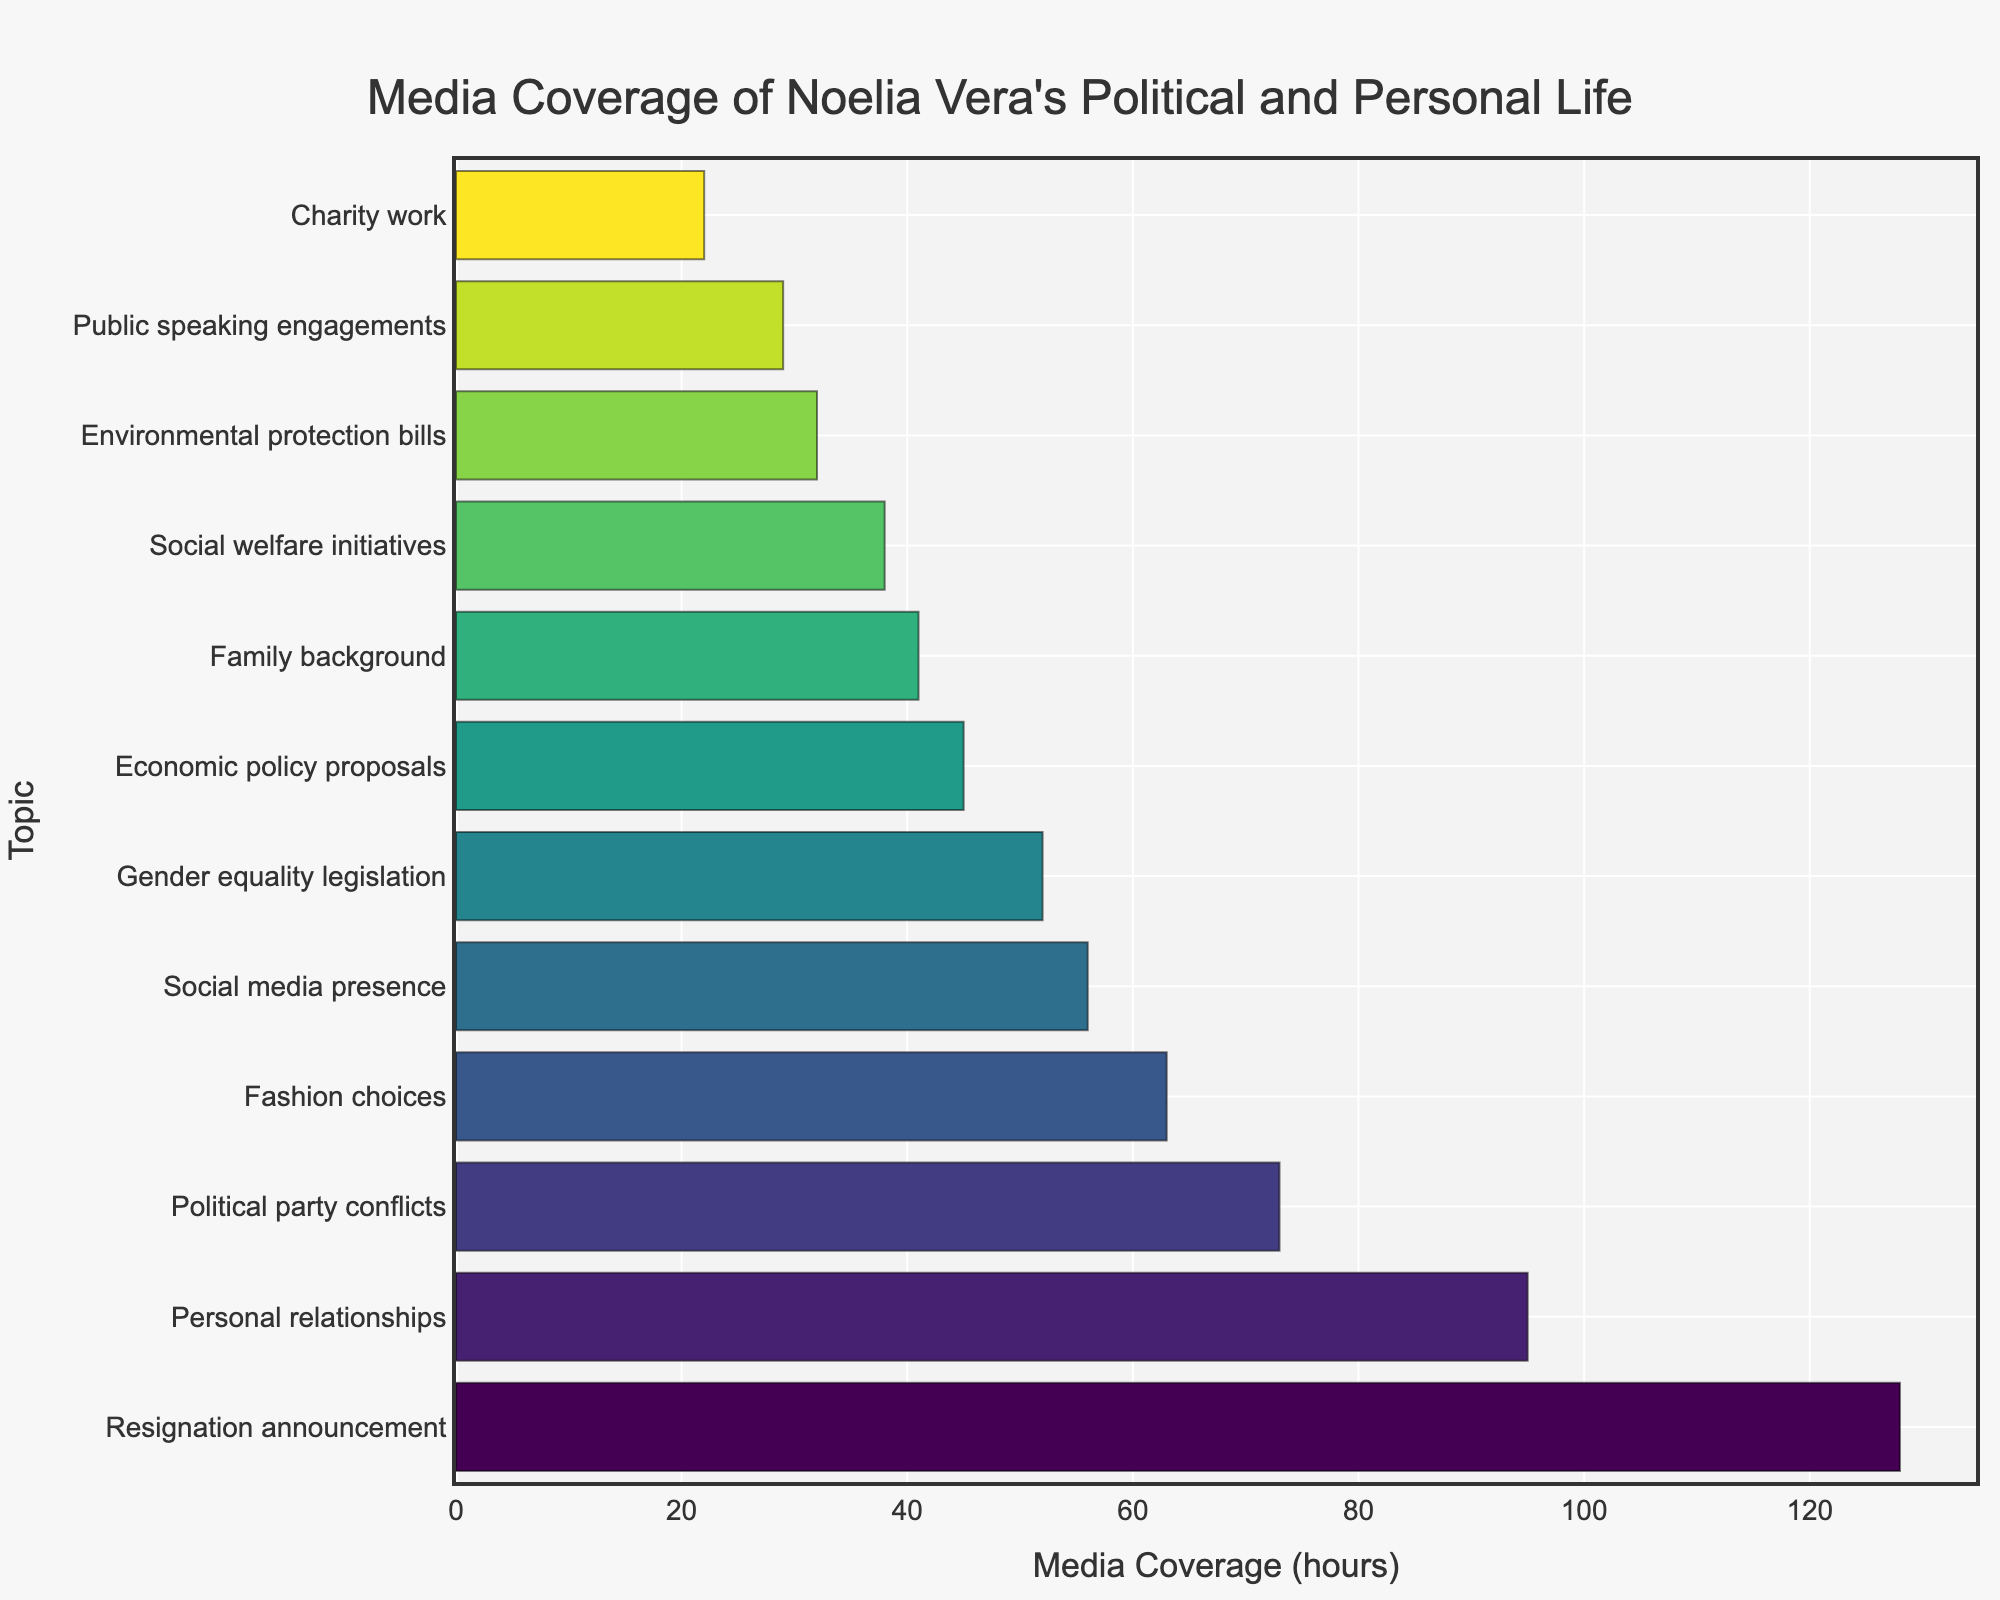What topic received the highest media coverage? The bar chart shows the 'Resignation announcement' with the longest bar on the horizontal axis, indicating it received the highest media coverage.
Answer: Resignation announcement How much more media coverage did 'Personal relationships' receive compared to 'Charity work'? According to the chart, 'Personal relationships' received 95 hours of media coverage and 'Charity work' received 22 hours. The difference is 95 - 22 = 73 hours.
Answer: 73 hours Which political initiative received the least media coverage? The shortest bar within the political initiatives category is for 'Public speaking engagements,' indicating it has the least coverage among that group.
Answer: Public speaking engagements What is the total media coverage for 'Economic policy proposals', 'Social welfare initiatives', and 'Environmental protection bills'? Adding the hours for these topics: 45 (Economic policy proposals) + 38 (Social welfare initiatives) + 32 (Environmental protection bills). Therefore, the total is 45 + 38 + 32 = 115 hours.
Answer: 115 hours Compare the media coverage of 'Gender equality legislation' with 'Political party conflicts'. The bar chart shows that 'Gender equality legislation' received 52 hours of media coverage, while 'Political party conflicts' received 73 hours. The comparison shows that 'Political party conflicts' received more coverage.
Answer: Political party conflicts received more Which topic has approximately half the media coverage of 'Resignation announcement'? The 'Resignation announcement' received 128 hours. The horizontal bar for 'Political party conflicts' which has 73 hours, is approximately half of 128 hours.
Answer: Political party conflicts What is the average media coverage for 'Charity work' and 'Family background'? 'Charity work' has 22 hours of media coverage and 'Family background' has 41 hours. The average is calculated by (22 + 41) / 2 = 63 / 2 = 31.5 hours.
Answer: 31.5 hours How does the media coverage of 'Public speaking engagements' compare to 'Social media presence'? The chart shows that 'Public speaking engagements' have 29 hours, while 'Social media presence' has 56 hours of media coverage, making 'Social media presence' coverage almost double.
Answer: Social media presence has more What is the sum of media coverage hours for the top three topics? The top three topics by media coverage are 'Resignation announcement' (128), 'Personal relationships' (95), and 'Political party conflicts' (73). The sum is 128 + 95 + 73 = 296 hours.
Answer: 296 hours Which visual attribute helps in identifying the difference in coverage between the 'Environmental protection bills' and 'Fashion choices'? The chart utilizes bar length to represent media coverage. 'Fashion choices' has a longer bar at 63 hours compared to 'Environmental protection bills' at 32 hours, visually showing the difference.
Answer: Bar length 